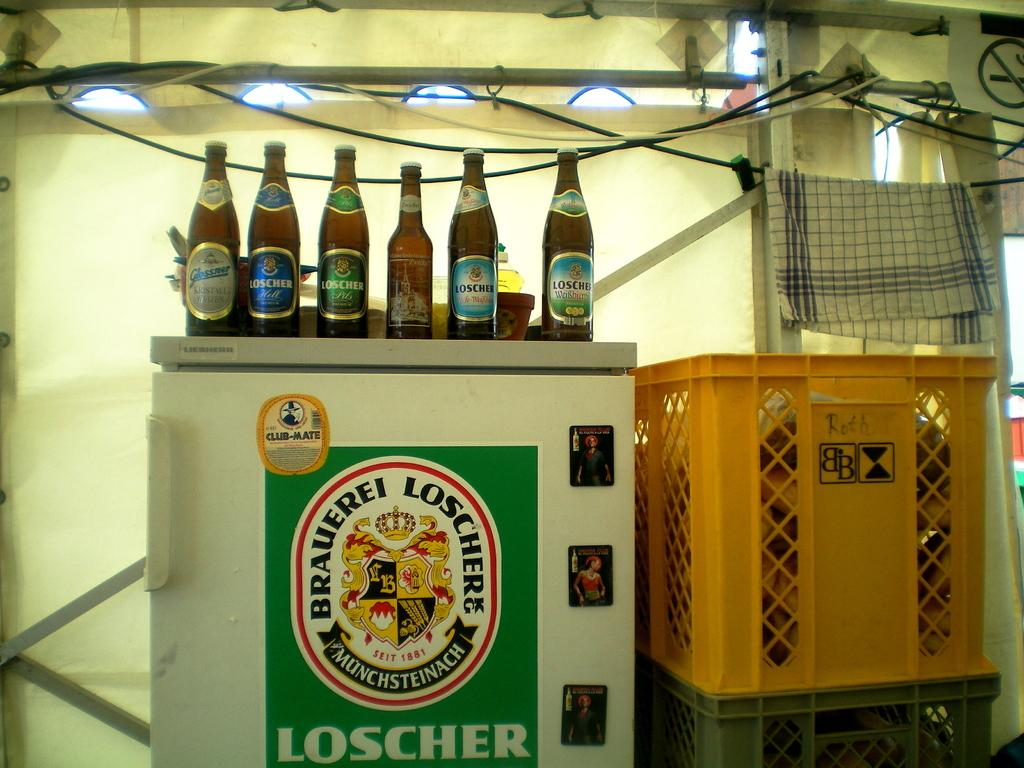<image>
Present a compact description of the photo's key features. Beer bottle with a blue label for Loscher next to other beers. 